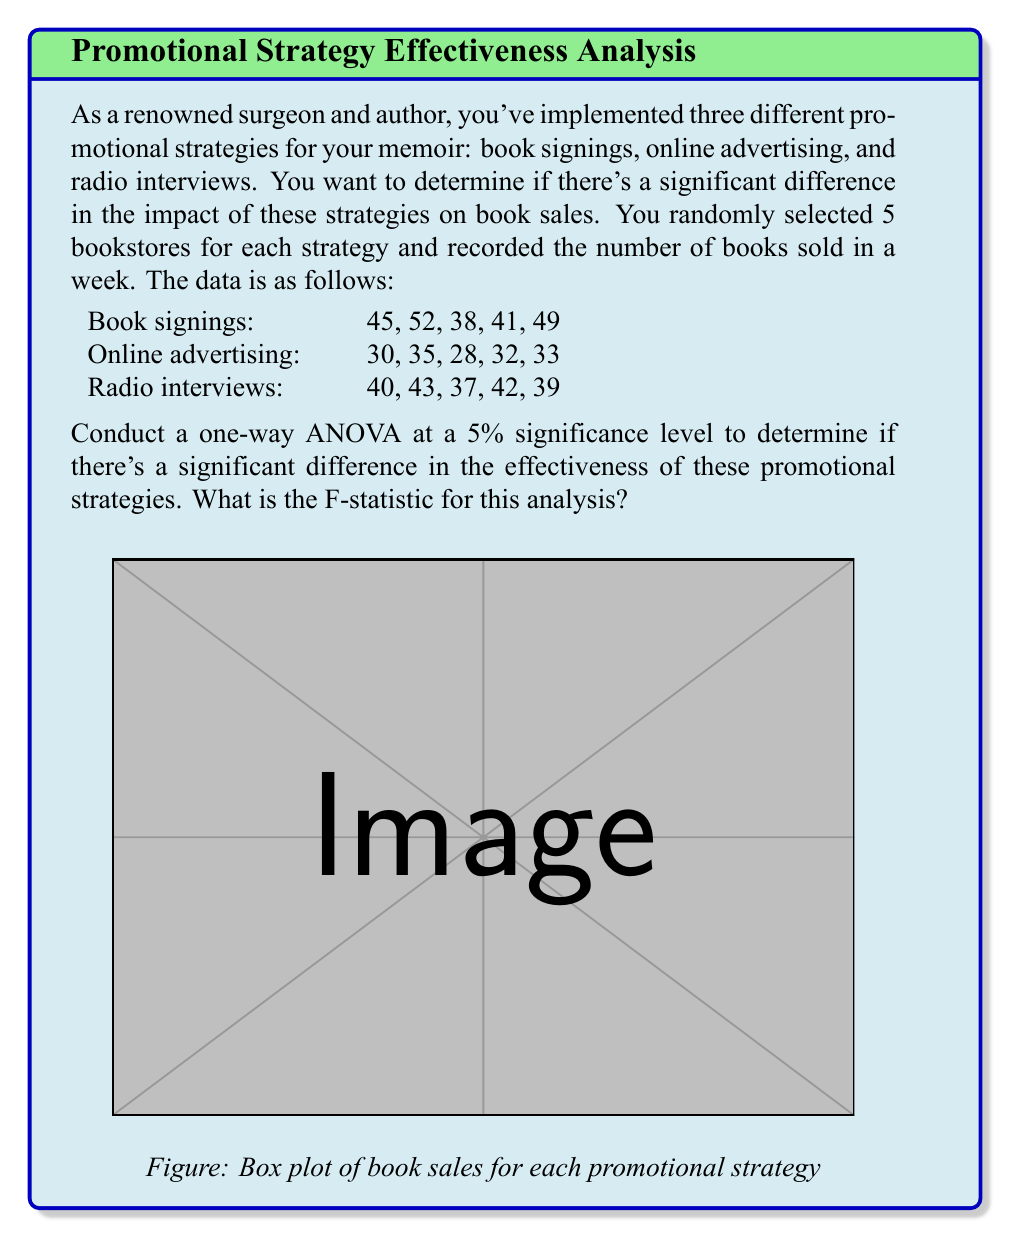Help me with this question. To conduct a one-way ANOVA, we need to follow these steps:

1) Calculate the sum of squares between groups (SSB):
   First, calculate the mean for each group and the overall mean.
   
   Book signings mean: $\bar{x}_1 = \frac{45 + 52 + 38 + 41 + 49}{5} = 45$
   Online advertising mean: $\bar{x}_2 = \frac{30 + 35 + 28 + 32 + 33}{5} = 31.6$
   Radio interviews mean: $\bar{x}_3 = \frac{40 + 43 + 37 + 42 + 39}{5} = 40.2$
   
   Overall mean: $\bar{x} = \frac{45 + 31.6 + 40.2}{3} = 38.93$

   SSB = $\sum_{i=1}^{k} n_i(\bar{x}_i - \bar{x})^2$
       = $5[(45 - 38.93)^2 + (31.6 - 38.93)^2 + (40.2 - 38.93)^2]$
       = $5[36.72 + 53.55 + 1.62] = 459.45$

2) Calculate the sum of squares within groups (SSW):
   SSW = $\sum_{i=1}^{k} \sum_{j=1}^{n_i} (x_{ij} - \bar{x}_i)^2$
       = $[(45-45)^2 + (52-45)^2 + (38-45)^2 + (41-45)^2 + (49-45)^2]$
       + $[(30-31.6)^2 + (35-31.6)^2 + (28-31.6)^2 + (32-31.6)^2 + (33-31.6)^2]$
       + $[(40-40.2)^2 + (43-40.2)^2 + (37-40.2)^2 + (42-40.2)^2 + (39-40.2)^2]$
       = $146 + 44.8 + 30.8 = 221.6$

3) Calculate degrees of freedom:
   Between groups: $df_B = k - 1 = 3 - 1 = 2$
   Within groups: $df_W = N - k = 15 - 3 = 12$

4) Calculate mean squares:
   MSB = $\frac{SSB}{df_B} = \frac{459.45}{2} = 229.725$
   MSW = $\frac{SSW}{df_W} = \frac{221.6}{12} = 18.467$

5) Calculate F-statistic:
   $F = \frac{MSB}{MSW} = \frac{229.725}{18.467} = 12.44$

Therefore, the F-statistic for this analysis is 12.44.
Answer: 12.44 